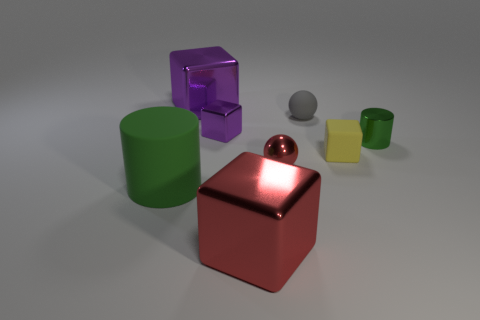Could you describe the positioning of the different shapes with respect to the large metal cube? Certainly! The large metal cube is centrally located. To its immediate right, there is a purple transparent cube. In front of the large cube, slightly to the left, sits a small gray sphere. Directly in front of the metal cube, a green cylinder is visible. Off to the left, the red sphere is noticeable, and finally, a small yellow cube is situated behind the green cylinder. 